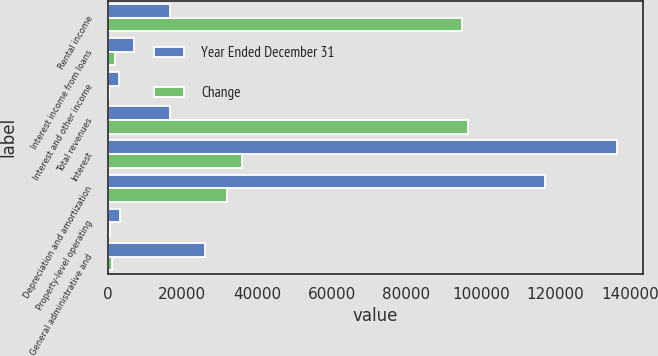Convert chart to OTSL. <chart><loc_0><loc_0><loc_500><loc_500><stacked_bar_chart><ecel><fcel>Rental income<fcel>Interest income from loans<fcel>Interest and other income<fcel>Total revenues<fcel>Interest<fcel>Depreciation and amortization<fcel>Property-level operating<fcel>General administrative and<nl><fcel>Year Ended December 31<fcel>16575<fcel>7014<fcel>2886<fcel>16575<fcel>136544<fcel>117172<fcel>3171<fcel>26136<nl><fcel>Change<fcel>95037<fcel>2013<fcel>382<fcel>96668<fcel>36113<fcel>31853<fcel>595<fcel>1061<nl></chart> 